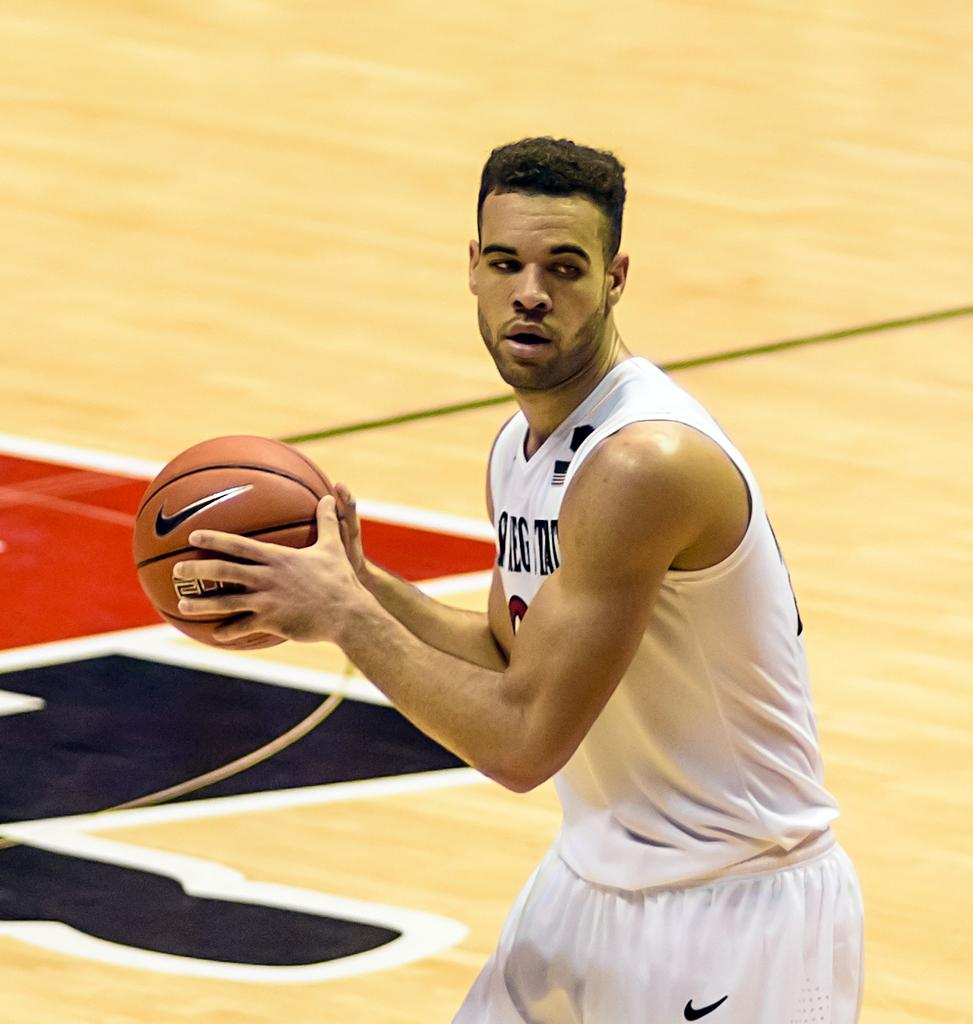Who is the main subject in the picture? There is a man in the center of the picture. What is the man wearing? The man is wearing a white jersey. What is the man holding in the picture? The man is holding a basketball. Where is the man located in the image? The man is on a basketball court. What type of sand can be seen on the tray in the image? There is no sand or tray present in the image; it features a man on a basketball court holding a basketball. 